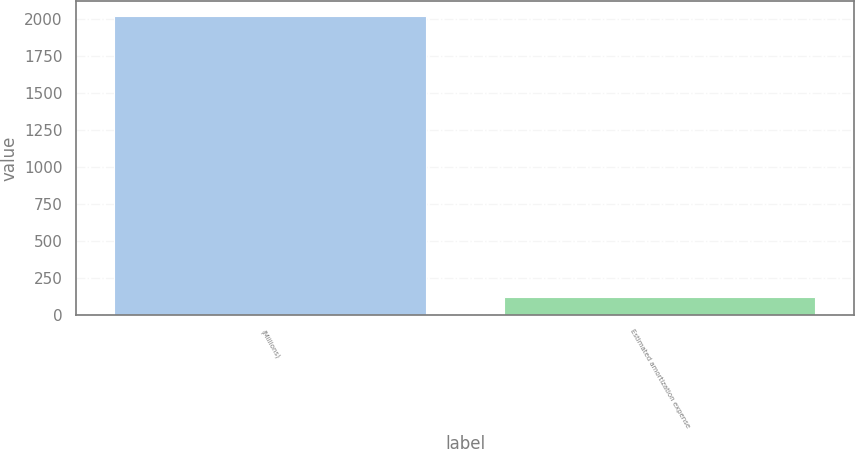Convert chart. <chart><loc_0><loc_0><loc_500><loc_500><bar_chart><fcel>(Millions)<fcel>Estimated amortization expense<nl><fcel>2020<fcel>121<nl></chart> 